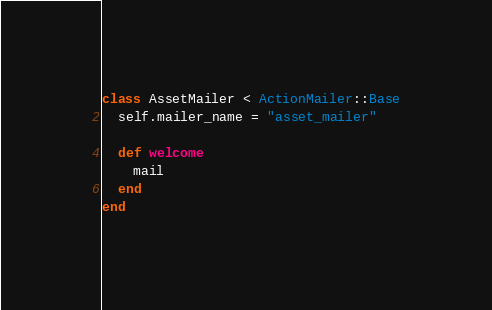<code> <loc_0><loc_0><loc_500><loc_500><_Ruby_>class AssetMailer < ActionMailer::Base
  self.mailer_name = "asset_mailer"

  def welcome
    mail
  end
end
</code> 